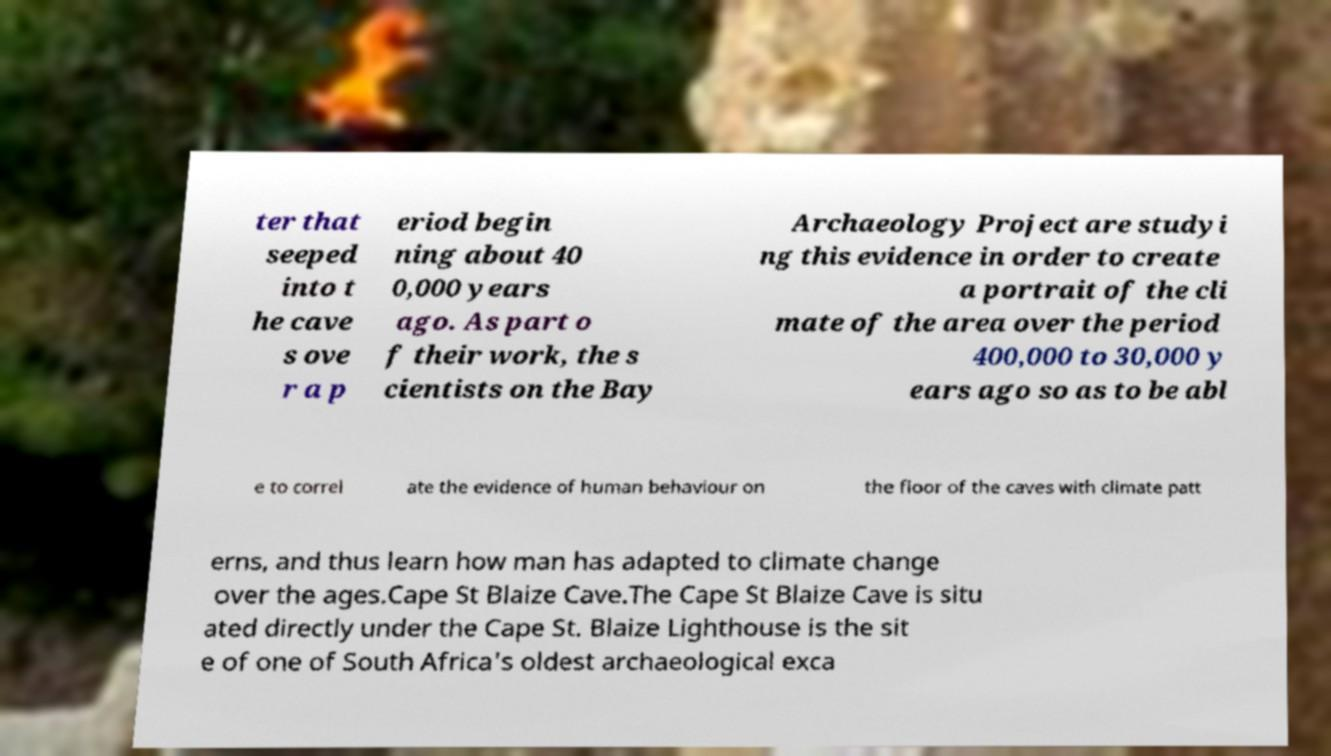Could you extract and type out the text from this image? ter that seeped into t he cave s ove r a p eriod begin ning about 40 0,000 years ago. As part o f their work, the s cientists on the Bay Archaeology Project are studyi ng this evidence in order to create a portrait of the cli mate of the area over the period 400,000 to 30,000 y ears ago so as to be abl e to correl ate the evidence of human behaviour on the floor of the caves with climate patt erns, and thus learn how man has adapted to climate change over the ages.Cape St Blaize Cave.The Cape St Blaize Cave is situ ated directly under the Cape St. Blaize Lighthouse is the sit e of one of South Africa's oldest archaeological exca 